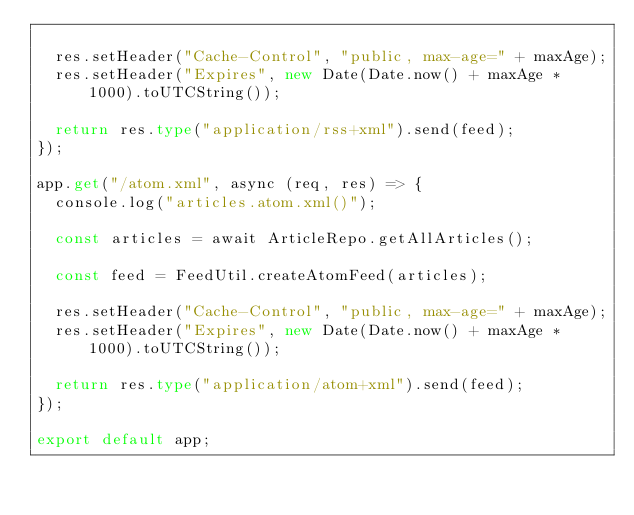<code> <loc_0><loc_0><loc_500><loc_500><_TypeScript_>  
  res.setHeader("Cache-Control", "public, max-age=" + maxAge);
  res.setHeader("Expires", new Date(Date.now() + maxAge * 1000).toUTCString());

  return res.type("application/rss+xml").send(feed);
});

app.get("/atom.xml", async (req, res) => {
  console.log("articles.atom.xml()");

  const articles = await ArticleRepo.getAllArticles();

  const feed = FeedUtil.createAtomFeed(articles);

  res.setHeader("Cache-Control", "public, max-age=" + maxAge);
  res.setHeader("Expires", new Date(Date.now() + maxAge * 1000).toUTCString());
  
  return res.type("application/atom+xml").send(feed);
});

export default app;</code> 